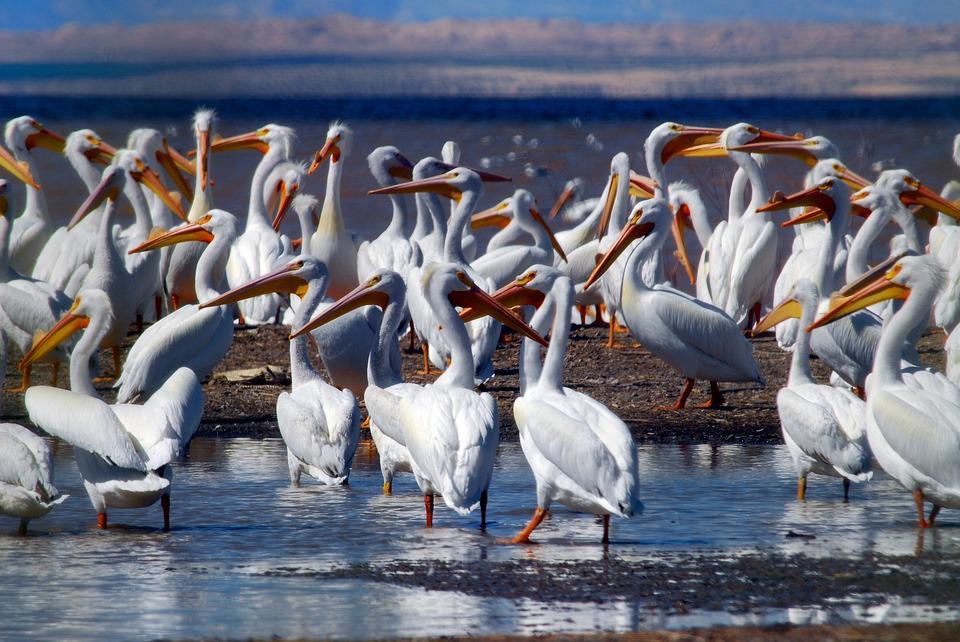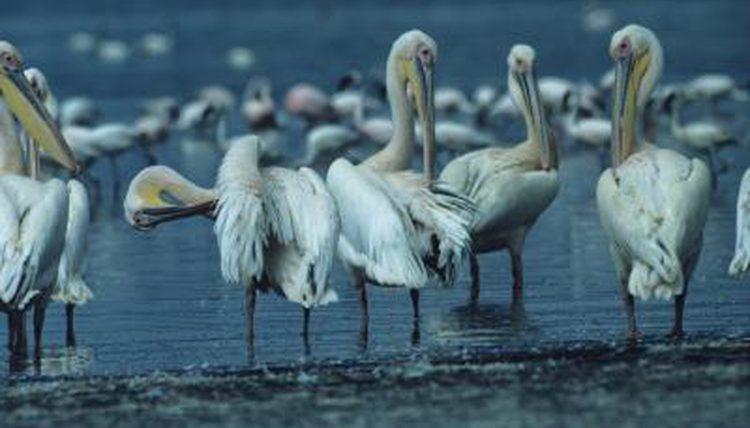The first image is the image on the left, the second image is the image on the right. Examine the images to the left and right. Is the description "Multiple birds are in flight in one image." accurate? Answer yes or no. No. The first image is the image on the left, the second image is the image on the right. Considering the images on both sides, is "Some of the birds are standing in the water." valid? Answer yes or no. Yes. 